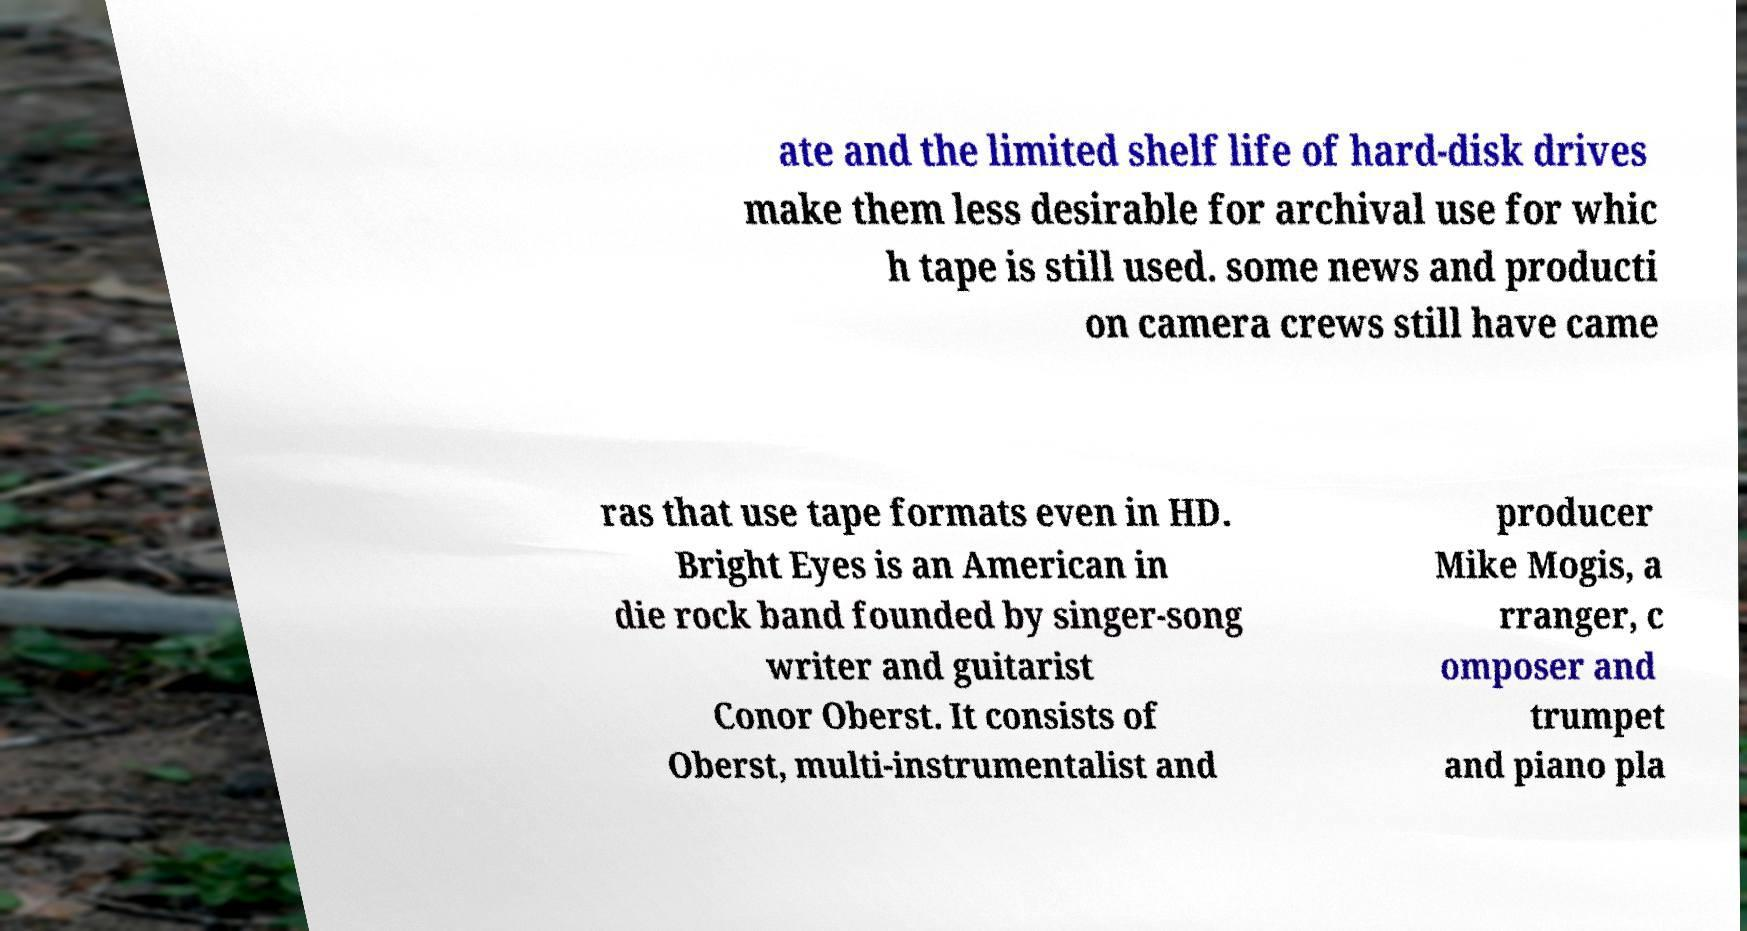Please identify and transcribe the text found in this image. ate and the limited shelf life of hard-disk drives make them less desirable for archival use for whic h tape is still used. some news and producti on camera crews still have came ras that use tape formats even in HD. Bright Eyes is an American in die rock band founded by singer-song writer and guitarist Conor Oberst. It consists of Oberst, multi-instrumentalist and producer Mike Mogis, a rranger, c omposer and trumpet and piano pla 